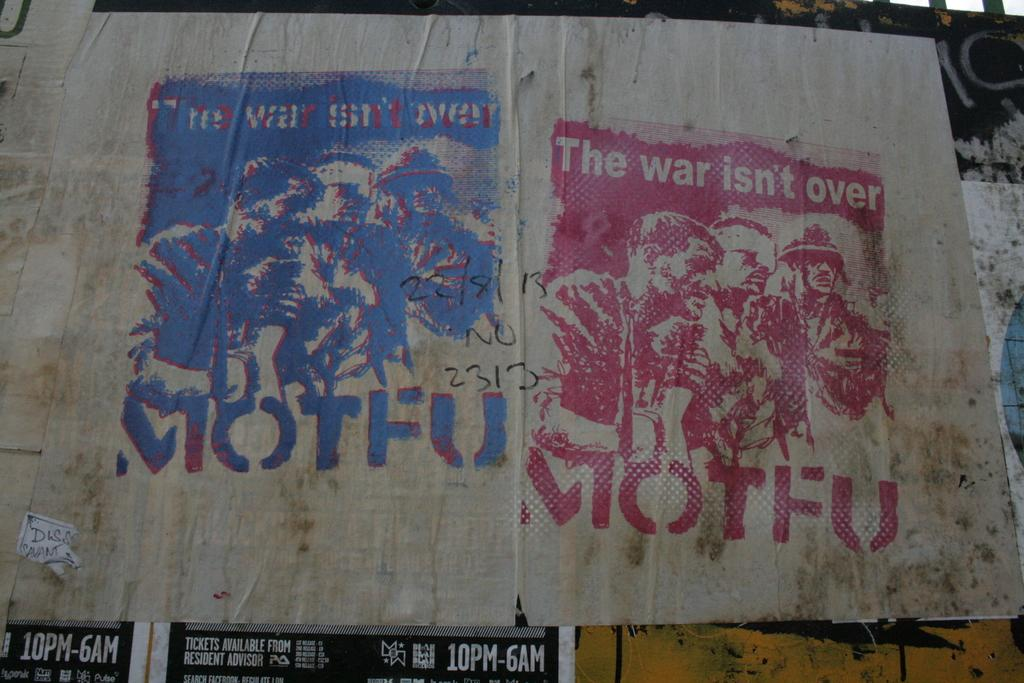What is featured on the poster in the image? There is a poster with text in the image. Where can additional text be found in the image? There are stickers with text in the left bottom corner of the image. What type of board is the duck riding on in the image? There is no board or duck present in the image; it only features a poster and stickers with text. 